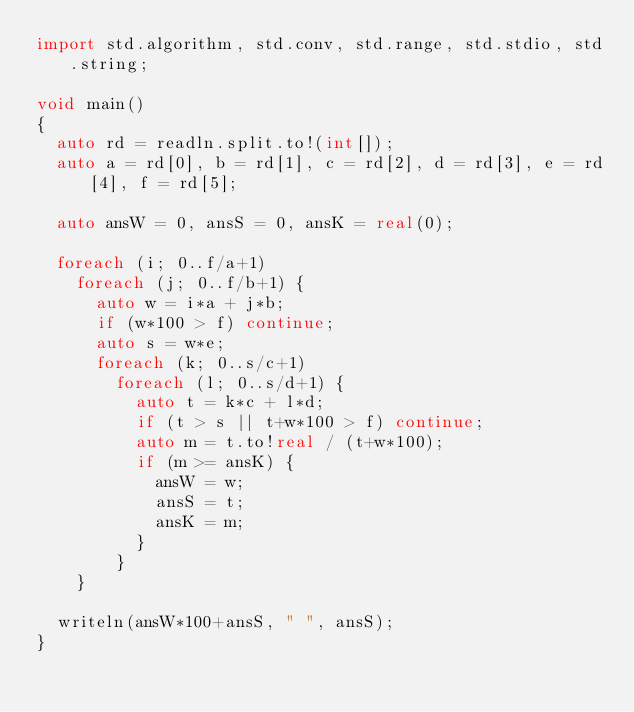Convert code to text. <code><loc_0><loc_0><loc_500><loc_500><_D_>import std.algorithm, std.conv, std.range, std.stdio, std.string;

void main()
{
  auto rd = readln.split.to!(int[]);
  auto a = rd[0], b = rd[1], c = rd[2], d = rd[3], e = rd[4], f = rd[5];

  auto ansW = 0, ansS = 0, ansK = real(0);

  foreach (i; 0..f/a+1)
    foreach (j; 0..f/b+1) {
      auto w = i*a + j*b;
      if (w*100 > f) continue;
      auto s = w*e;
      foreach (k; 0..s/c+1)
        foreach (l; 0..s/d+1) {
          auto t = k*c + l*d;
          if (t > s || t+w*100 > f) continue;
          auto m = t.to!real / (t+w*100);
          if (m >= ansK) {
            ansW = w;
            ansS = t;
            ansK = m;
          }
        }
    }

  writeln(ansW*100+ansS, " ", ansS);
}
</code> 